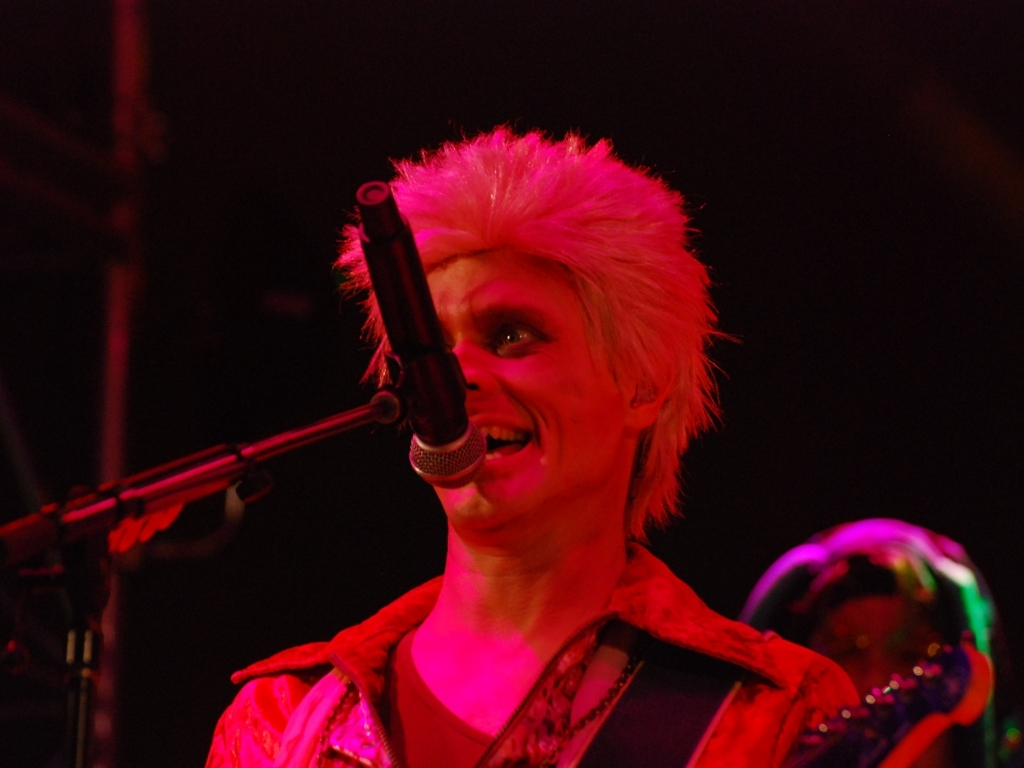Could you speculate on the era or context this performance might be taking place in based on the singer's appearance? Considering the singer's bold hair and costume choice resembling styles from the 1970s and 1980s, it's plausible that the performance is either from that time period or is a modern act drawing inspiration from the glam rock or punk movements of those decades. 